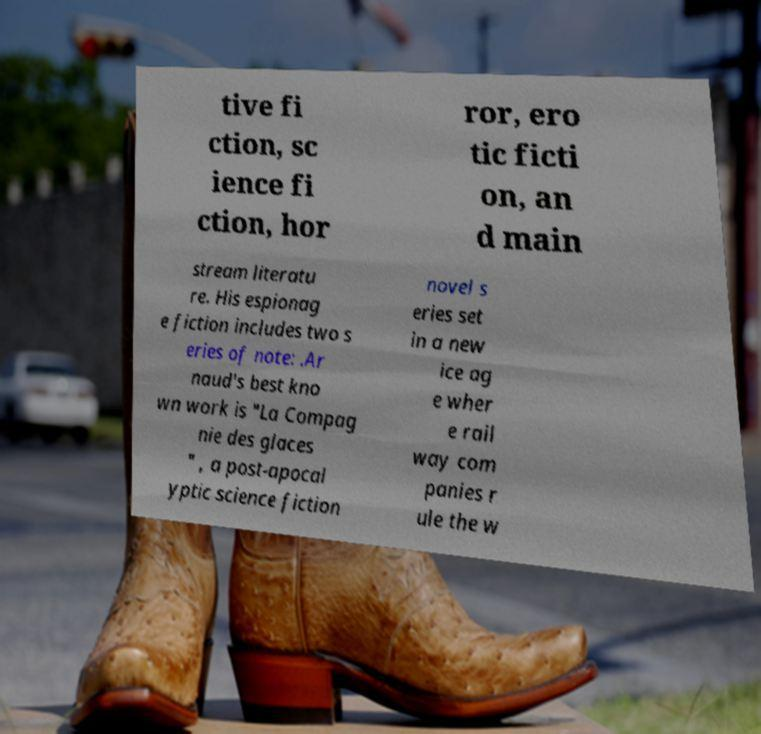Can you read and provide the text displayed in the image?This photo seems to have some interesting text. Can you extract and type it out for me? tive fi ction, sc ience fi ction, hor ror, ero tic ficti on, an d main stream literatu re. His espionag e fiction includes two s eries of note: .Ar naud's best kno wn work is "La Compag nie des glaces " , a post-apocal yptic science fiction novel s eries set in a new ice ag e wher e rail way com panies r ule the w 